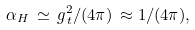<formula> <loc_0><loc_0><loc_500><loc_500>\alpha _ { H } \, \simeq \, g _ { \, t } ^ { 2 } / ( 4 \pi ) \, \approx 1 / ( 4 \pi ) ,</formula> 